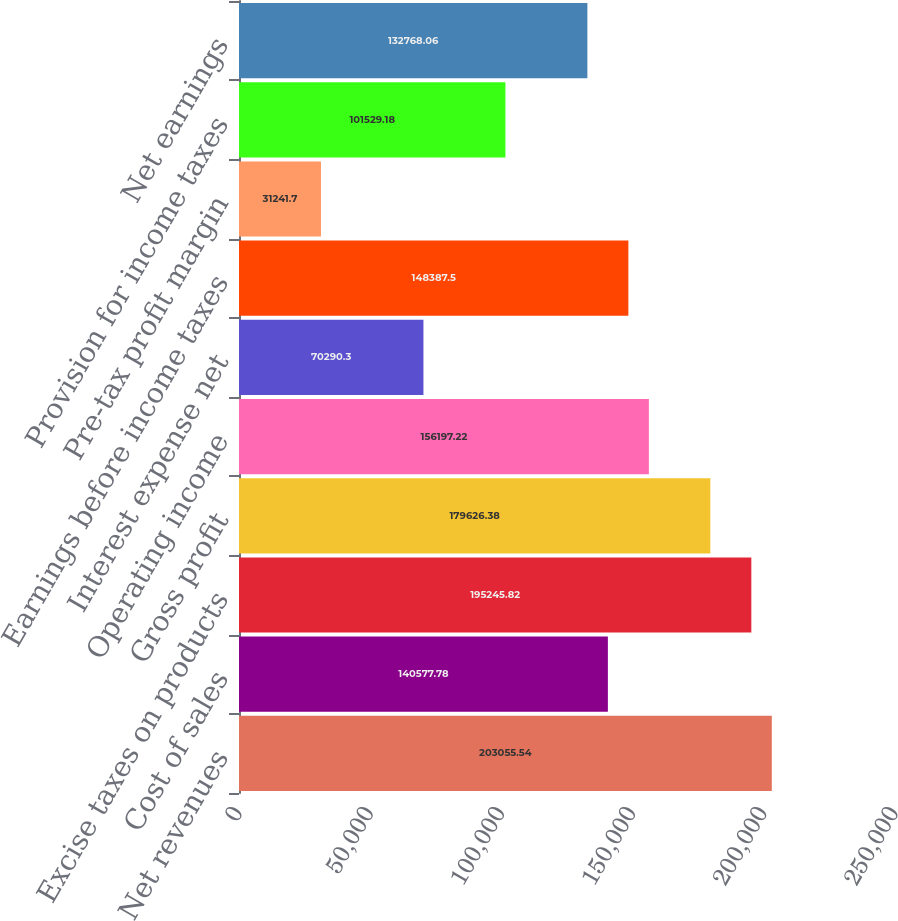Convert chart to OTSL. <chart><loc_0><loc_0><loc_500><loc_500><bar_chart><fcel>Net revenues<fcel>Cost of sales<fcel>Excise taxes on products<fcel>Gross profit<fcel>Operating income<fcel>Interest expense net<fcel>Earnings before income taxes<fcel>Pre-tax profit margin<fcel>Provision for income taxes<fcel>Net earnings<nl><fcel>203056<fcel>140578<fcel>195246<fcel>179626<fcel>156197<fcel>70290.3<fcel>148388<fcel>31241.7<fcel>101529<fcel>132768<nl></chart> 